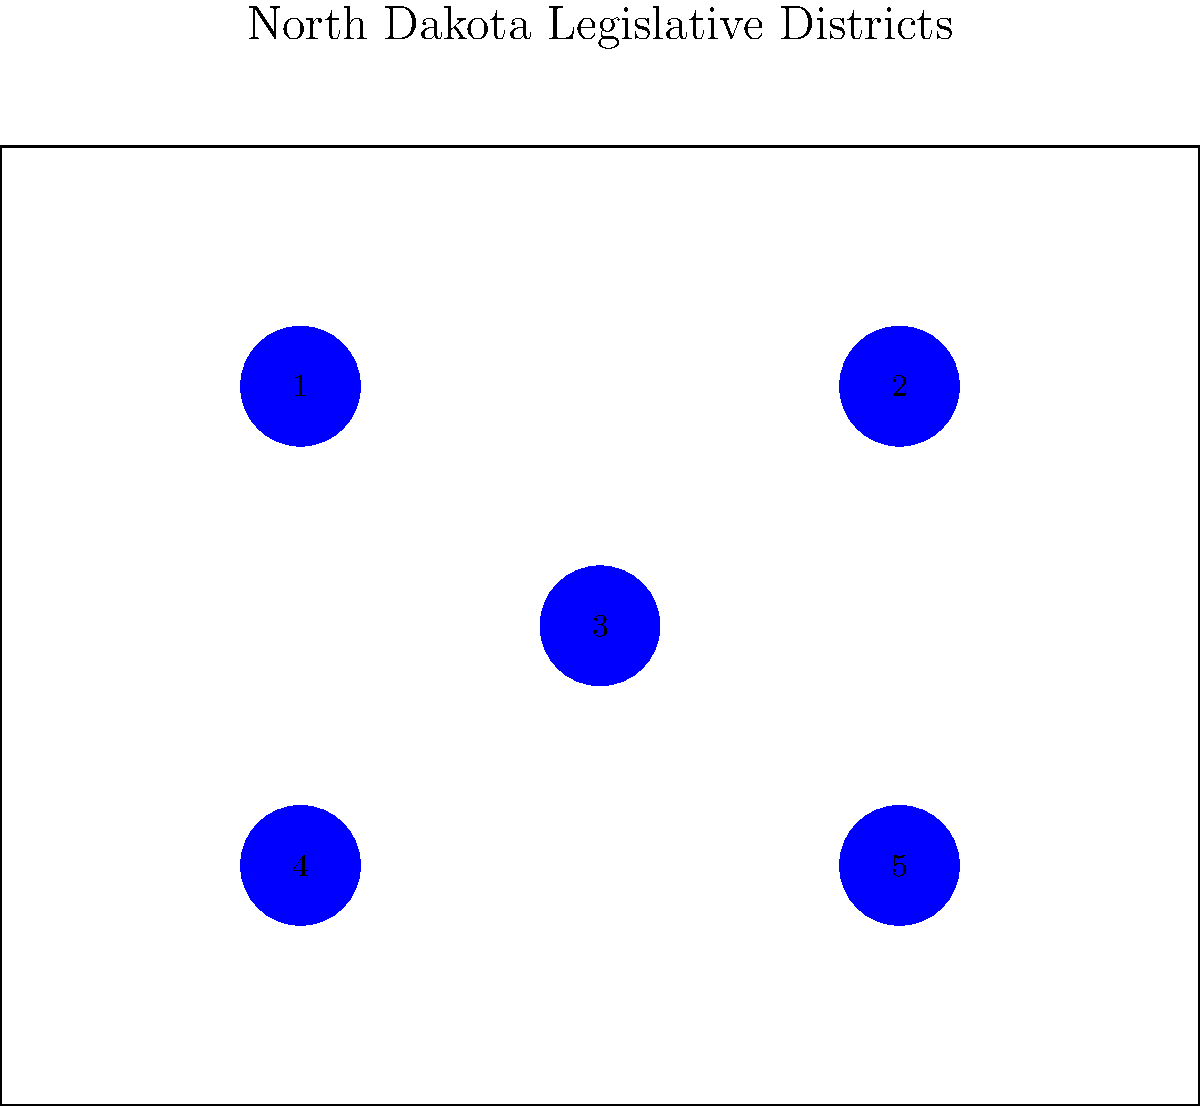Based on the map of North Dakota's legislative districts, which two districts are most likely to be Democratic strongholds in the state? To identify the Democratic strongholds in North Dakota's legislative districts, we need to consider several factors:

1. Urban areas: Democratic support is typically stronger in urban centers.
2. College towns: Areas with higher education institutions often lean Democratic.
3. Native American reservations: These areas tend to support Democratic candidates.

Considering these factors for North Dakota:

1. District 1 includes Grand Forks, home to the University of North Dakota, making it a potential Democratic stronghold due to the urban area and college population.

2. District 3 includes Fargo, the largest city in North Dakota and home to North Dakota State University. This urban area with a significant college population is likely to be a Democratic stronghold.

3. Districts 2, 4, and 5 are more rural and traditionally lean Republican in North Dakota.

Therefore, based on this analysis, Districts 1 and 3 are the most likely to be Democratic strongholds in North Dakota.
Answer: Districts 1 and 3 